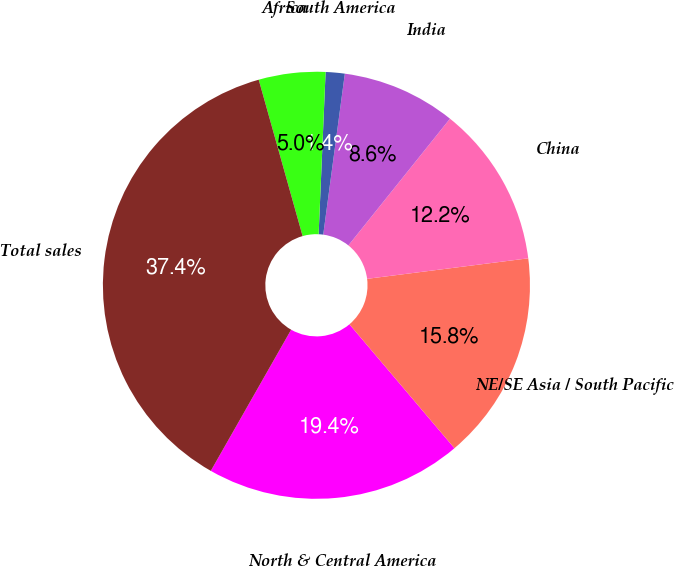Convert chart to OTSL. <chart><loc_0><loc_0><loc_500><loc_500><pie_chart><fcel>North & Central America<fcel>NE/SE Asia / South Pacific<fcel>China<fcel>India<fcel>South America<fcel>Africa<fcel>Total sales<nl><fcel>19.42%<fcel>15.83%<fcel>12.23%<fcel>8.63%<fcel>1.44%<fcel>5.04%<fcel>37.41%<nl></chart> 